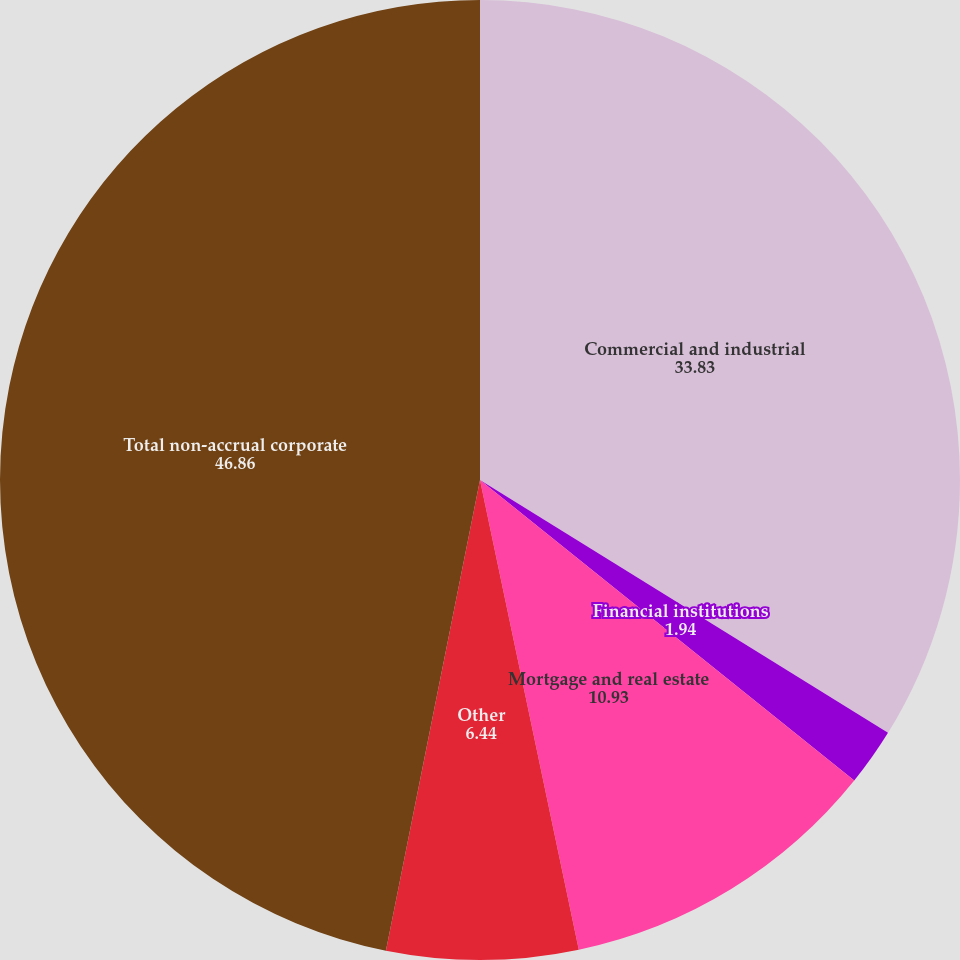Convert chart to OTSL. <chart><loc_0><loc_0><loc_500><loc_500><pie_chart><fcel>Commercial and industrial<fcel>Financial institutions<fcel>Mortgage and real estate<fcel>Other<fcel>Total non-accrual corporate<nl><fcel>33.83%<fcel>1.94%<fcel>10.93%<fcel>6.44%<fcel>46.86%<nl></chart> 